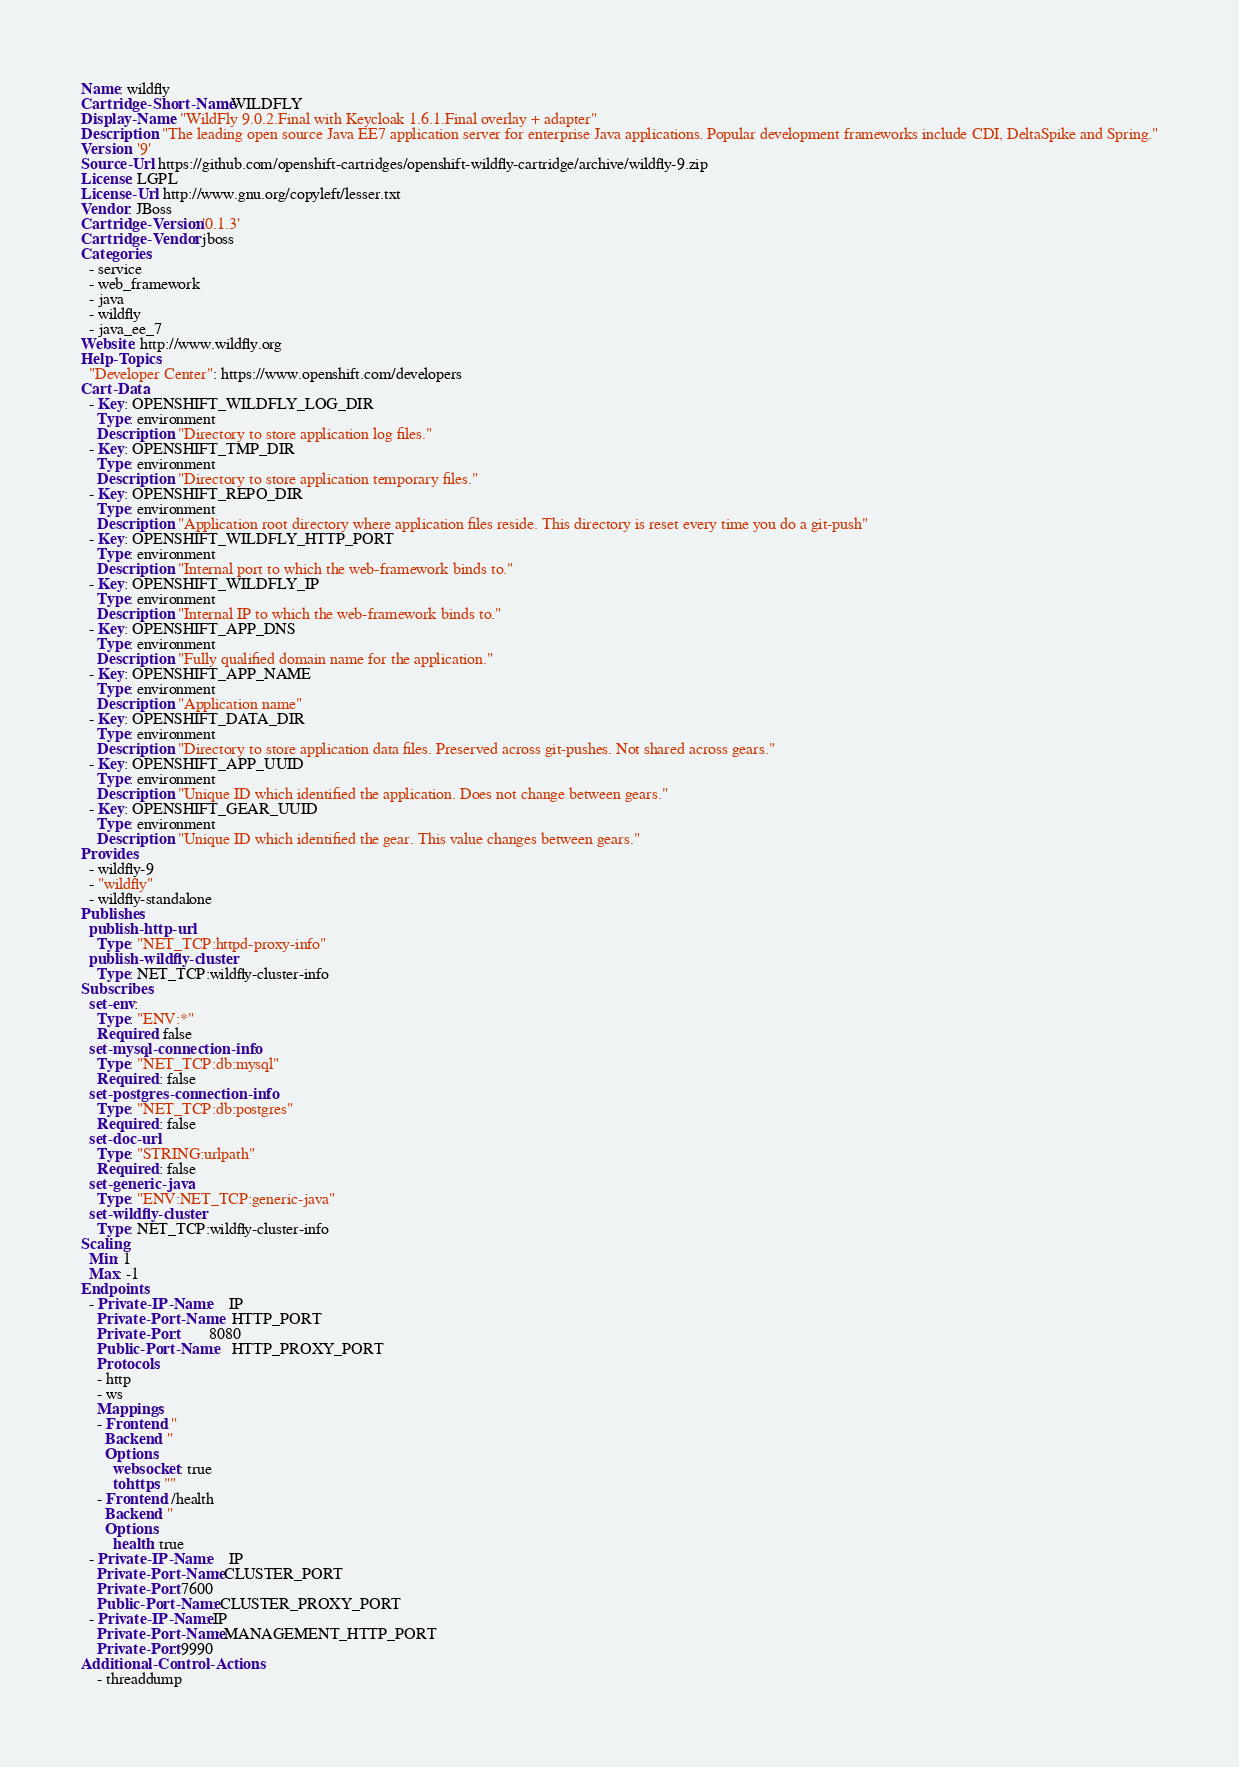Convert code to text. <code><loc_0><loc_0><loc_500><loc_500><_YAML_>Name: wildfly
Cartridge-Short-Name: WILDFLY
Display-Name: "WildFly 9.0.2.Final with Keycloak 1.6.1.Final overlay + adapter"
Description: "The leading open source Java EE7 application server for enterprise Java applications. Popular development frameworks include CDI, DeltaSpike and Spring."
Version: '9'
Source-Url: https://github.com/openshift-cartridges/openshift-wildfly-cartridge/archive/wildfly-9.zip
License: LGPL
License-Url: http://www.gnu.org/copyleft/lesser.txt
Vendor: JBoss
Cartridge-Version: '0.1.3'
Cartridge-Vendor: jboss
Categories:
  - service
  - web_framework
  - java
  - wildfly
  - java_ee_7
Website: http://www.wildfly.org
Help-Topics:
  "Developer Center": https://www.openshift.com/developers
Cart-Data:
  - Key: OPENSHIFT_WILDFLY_LOG_DIR
    Type: environment
    Description: "Directory to store application log files."
  - Key: OPENSHIFT_TMP_DIR
    Type: environment
    Description: "Directory to store application temporary files."
  - Key: OPENSHIFT_REPO_DIR
    Type: environment
    Description: "Application root directory where application files reside. This directory is reset every time you do a git-push"
  - Key: OPENSHIFT_WILDFLY_HTTP_PORT
    Type: environment
    Description: "Internal port to which the web-framework binds to."
  - Key: OPENSHIFT_WILDFLY_IP
    Type: environment
    Description: "Internal IP to which the web-framework binds to."
  - Key: OPENSHIFT_APP_DNS
    Type: environment
    Description: "Fully qualified domain name for the application."
  - Key: OPENSHIFT_APP_NAME
    Type: environment
    Description: "Application name"
  - Key: OPENSHIFT_DATA_DIR
    Type: environment
    Description: "Directory to store application data files. Preserved across git-pushes. Not shared across gears."
  - Key: OPENSHIFT_APP_UUID
    Type: environment
    Description: "Unique ID which identified the application. Does not change between gears."
  - Key: OPENSHIFT_GEAR_UUID
    Type: environment
    Description: "Unique ID which identified the gear. This value changes between gears."
Provides:
  - wildfly-9
  - "wildfly"
  - wildfly-standalone
Publishes:
  publish-http-url:
    Type: "NET_TCP:httpd-proxy-info"
  publish-wildfly-cluster:
    Type: NET_TCP:wildfly-cluster-info
Subscribes:
  set-env:
    Type: "ENV:*"
    Required: false
  set-mysql-connection-info:
    Type: "NET_TCP:db:mysql"
    Required : false
  set-postgres-connection-info:
    Type: "NET_TCP:db:postgres"
    Required : false
  set-doc-url:
    Type: "STRING:urlpath"
    Required : false
  set-generic-java:
    Type: "ENV:NET_TCP:generic-java"
  set-wildfly-cluster:
    Type: NET_TCP:wildfly-cluster-info
Scaling:
  Min: 1
  Max: -1
Endpoints:
  - Private-IP-Name:     IP
    Private-Port-Name:   HTTP_PORT
    Private-Port:        8080
    Public-Port-Name:    HTTP_PROXY_PORT
    Protocols:
    - http
    - ws
    Mappings:
    - Frontend: ''
      Backend: ''
      Options:
        websocket: true
        tohttps: ""
    - Frontend: /health
      Backend: ''
      Options:
        health: true
  - Private-IP-Name:     IP
    Private-Port-Name: CLUSTER_PORT
    Private-Port: 7600
    Public-Port-Name: CLUSTER_PROXY_PORT
  - Private-IP-Name: IP
    Private-Port-Name: MANAGEMENT_HTTP_PORT
    Private-Port: 9990
Additional-Control-Actions:
    - threaddump
</code> 